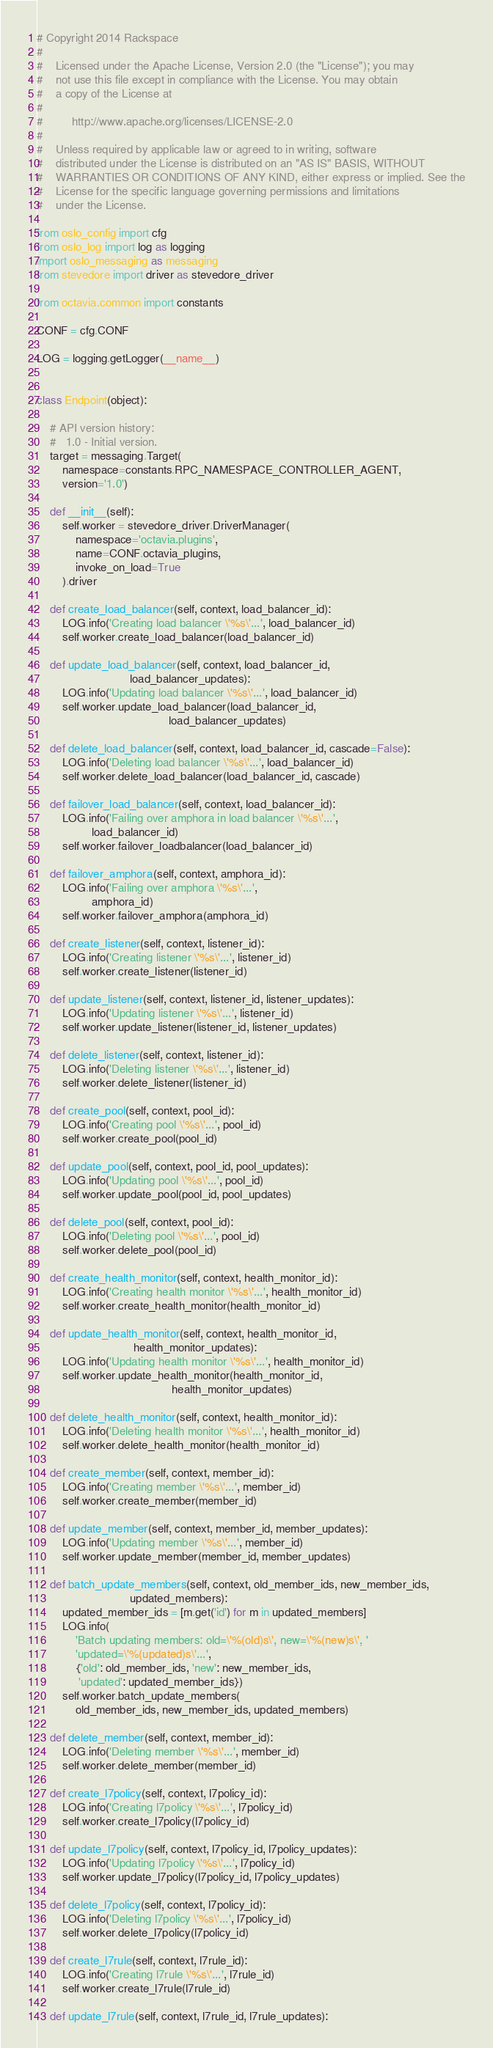Convert code to text. <code><loc_0><loc_0><loc_500><loc_500><_Python_># Copyright 2014 Rackspace
#
#    Licensed under the Apache License, Version 2.0 (the "License"); you may
#    not use this file except in compliance with the License. You may obtain
#    a copy of the License at
#
#         http://www.apache.org/licenses/LICENSE-2.0
#
#    Unless required by applicable law or agreed to in writing, software
#    distributed under the License is distributed on an "AS IS" BASIS, WITHOUT
#    WARRANTIES OR CONDITIONS OF ANY KIND, either express or implied. See the
#    License for the specific language governing permissions and limitations
#    under the License.

from oslo_config import cfg
from oslo_log import log as logging
import oslo_messaging as messaging
from stevedore import driver as stevedore_driver

from octavia.common import constants

CONF = cfg.CONF

LOG = logging.getLogger(__name__)


class Endpoint(object):

    # API version history:
    #   1.0 - Initial version.
    target = messaging.Target(
        namespace=constants.RPC_NAMESPACE_CONTROLLER_AGENT,
        version='1.0')

    def __init__(self):
        self.worker = stevedore_driver.DriverManager(
            namespace='octavia.plugins',
            name=CONF.octavia_plugins,
            invoke_on_load=True
        ).driver

    def create_load_balancer(self, context, load_balancer_id):
        LOG.info('Creating load balancer \'%s\'...', load_balancer_id)
        self.worker.create_load_balancer(load_balancer_id)

    def update_load_balancer(self, context, load_balancer_id,
                             load_balancer_updates):
        LOG.info('Updating load balancer \'%s\'...', load_balancer_id)
        self.worker.update_load_balancer(load_balancer_id,
                                         load_balancer_updates)

    def delete_load_balancer(self, context, load_balancer_id, cascade=False):
        LOG.info('Deleting load balancer \'%s\'...', load_balancer_id)
        self.worker.delete_load_balancer(load_balancer_id, cascade)

    def failover_load_balancer(self, context, load_balancer_id):
        LOG.info('Failing over amphora in load balancer \'%s\'...',
                 load_balancer_id)
        self.worker.failover_loadbalancer(load_balancer_id)

    def failover_amphora(self, context, amphora_id):
        LOG.info('Failing over amphora \'%s\'...',
                 amphora_id)
        self.worker.failover_amphora(amphora_id)

    def create_listener(self, context, listener_id):
        LOG.info('Creating listener \'%s\'...', listener_id)
        self.worker.create_listener(listener_id)

    def update_listener(self, context, listener_id, listener_updates):
        LOG.info('Updating listener \'%s\'...', listener_id)
        self.worker.update_listener(listener_id, listener_updates)

    def delete_listener(self, context, listener_id):
        LOG.info('Deleting listener \'%s\'...', listener_id)
        self.worker.delete_listener(listener_id)

    def create_pool(self, context, pool_id):
        LOG.info('Creating pool \'%s\'...', pool_id)
        self.worker.create_pool(pool_id)

    def update_pool(self, context, pool_id, pool_updates):
        LOG.info('Updating pool \'%s\'...', pool_id)
        self.worker.update_pool(pool_id, pool_updates)

    def delete_pool(self, context, pool_id):
        LOG.info('Deleting pool \'%s\'...', pool_id)
        self.worker.delete_pool(pool_id)

    def create_health_monitor(self, context, health_monitor_id):
        LOG.info('Creating health monitor \'%s\'...', health_monitor_id)
        self.worker.create_health_monitor(health_monitor_id)

    def update_health_monitor(self, context, health_monitor_id,
                              health_monitor_updates):
        LOG.info('Updating health monitor \'%s\'...', health_monitor_id)
        self.worker.update_health_monitor(health_monitor_id,
                                          health_monitor_updates)

    def delete_health_monitor(self, context, health_monitor_id):
        LOG.info('Deleting health monitor \'%s\'...', health_monitor_id)
        self.worker.delete_health_monitor(health_monitor_id)

    def create_member(self, context, member_id):
        LOG.info('Creating member \'%s\'...', member_id)
        self.worker.create_member(member_id)

    def update_member(self, context, member_id, member_updates):
        LOG.info('Updating member \'%s\'...', member_id)
        self.worker.update_member(member_id, member_updates)

    def batch_update_members(self, context, old_member_ids, new_member_ids,
                             updated_members):
        updated_member_ids = [m.get('id') for m in updated_members]
        LOG.info(
            'Batch updating members: old=\'%(old)s\', new=\'%(new)s\', '
            'updated=\'%(updated)s\'...',
            {'old': old_member_ids, 'new': new_member_ids,
             'updated': updated_member_ids})
        self.worker.batch_update_members(
            old_member_ids, new_member_ids, updated_members)

    def delete_member(self, context, member_id):
        LOG.info('Deleting member \'%s\'...', member_id)
        self.worker.delete_member(member_id)

    def create_l7policy(self, context, l7policy_id):
        LOG.info('Creating l7policy \'%s\'...', l7policy_id)
        self.worker.create_l7policy(l7policy_id)

    def update_l7policy(self, context, l7policy_id, l7policy_updates):
        LOG.info('Updating l7policy \'%s\'...', l7policy_id)
        self.worker.update_l7policy(l7policy_id, l7policy_updates)

    def delete_l7policy(self, context, l7policy_id):
        LOG.info('Deleting l7policy \'%s\'...', l7policy_id)
        self.worker.delete_l7policy(l7policy_id)

    def create_l7rule(self, context, l7rule_id):
        LOG.info('Creating l7rule \'%s\'...', l7rule_id)
        self.worker.create_l7rule(l7rule_id)

    def update_l7rule(self, context, l7rule_id, l7rule_updates):</code> 